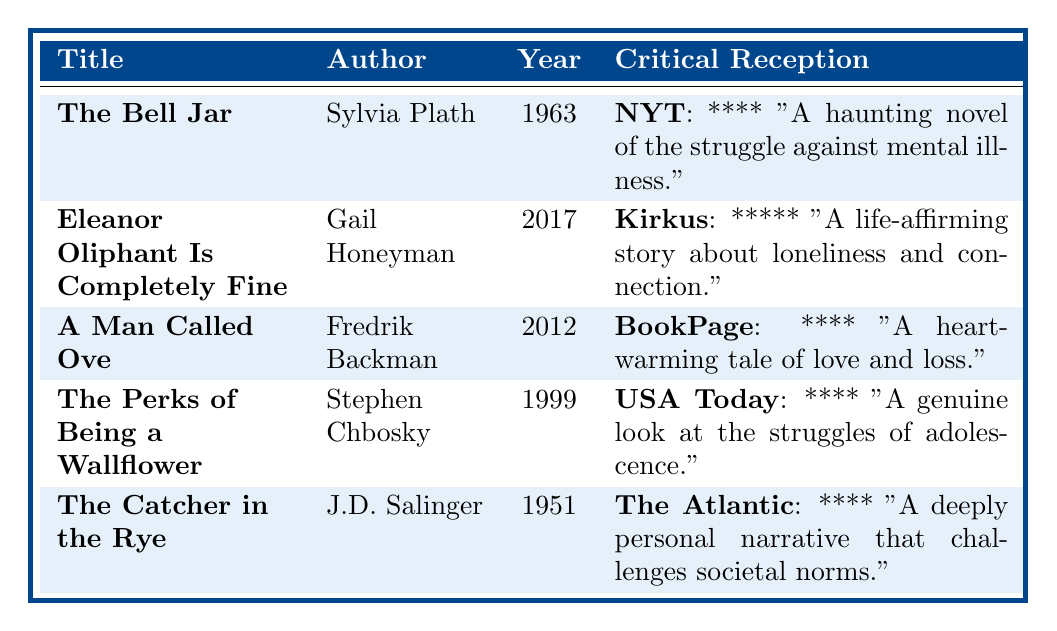What is the average rating of "The Bell Jar"? The average rating is listed directly in the table next to the title "The Bell Jar" and is 4.1.
Answer: 4.1 Which work received the highest average rating? By inspecting the average ratings in the table, "Eleanor Oliphant Is Completely Fine" has the highest average rating of 4.5.
Answer: Eleanor Oliphant Is Completely Fine Did "The Catcher in the Rye" receive a score of five stars from any critic? The critical reception column shows that both critics gave it four stars, so it did not receive a score of five stars from any critic.
Answer: No How many works have an average rating of 4.0 or more? Checking the average ratings, "The Bell Jar" (4.1), "Eleanor Oliphant Is Completely Fine" (4.5), "A Man Called Ove" (4.4), "The Perks of Being a Wallflower" (4.2), and "The Catcher in the Rye" (3.8) provide four works that meet that criteria.
Answer: Four What is the difference in average ratings between "Eleanor Oliphant Is Completely Fine" and "The Catcher in the Rye"? The average rating for "Eleanor Oliphant Is Completely Fine" is 4.5 and for "The Catcher in the Rye" is 3.8. Thus, the difference is 4.5 - 3.8 = 0.7.
Answer: 0.7 Which critic provided a review for "A Man Called Ove"? The table shows that both "BookPage" and "Entertainment Weekly" provided reviews for "A Man Called Ove".
Answer: Two critics Is "The Perks of Being a Wallflower" rated higher than "The Catcher in the Rye"? The average rating for "The Perks of Being a Wallflower" is 4.2, which is higher than "The Catcher in the Rye's" rating of 3.8, confirming it is rated higher.
Answer: Yes What is the combined number of stars received from critics for "The Bell Jar"? "The Bell Jar" received four stars from both "The New York Times" and "The Guardian," leading to a combined score of 8 stars.
Answer: 8 stars How does the average rating of "The Bell Jar" compare to "A Man Called Ove"? "The Bell Jar" has an average rating of 4.1, while "A Man Called Ove" has an average rating of 4.4. Comparing these, "A Man Called Ove" has a higher rating.
Answer: A Man Called Ove is higher Which work published last has the highest critical reception score? "Eleanor Oliphant Is Completely Fine" (2017) has the highest critical reception score of five stars among all the works listed.
Answer: Eleanor Oliphant Is Completely Fine 